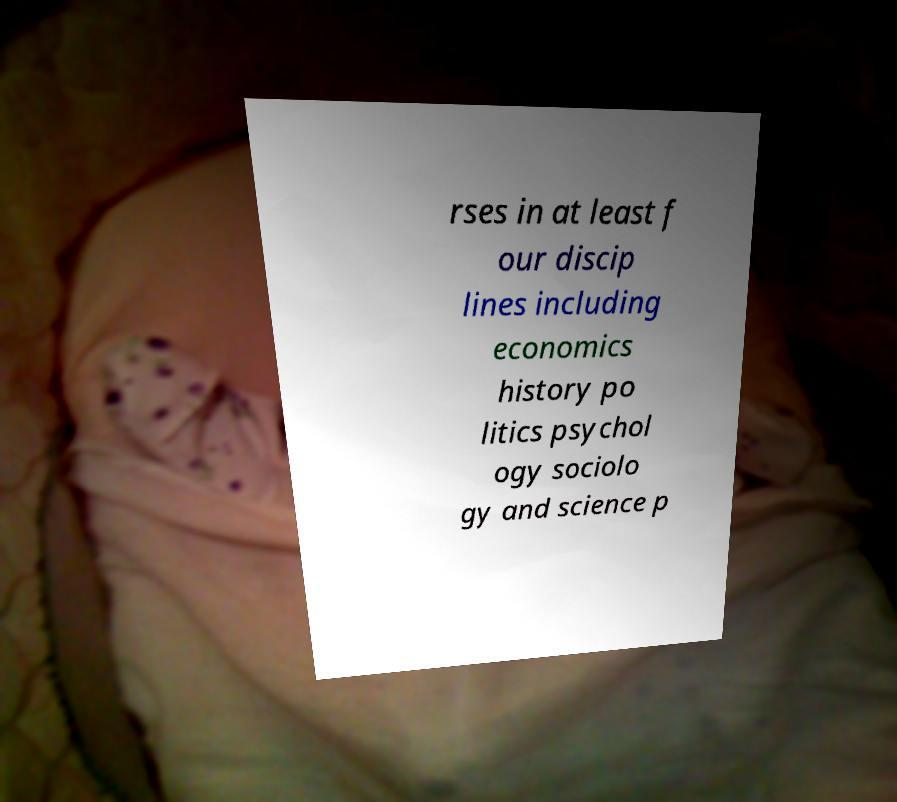Could you extract and type out the text from this image? rses in at least f our discip lines including economics history po litics psychol ogy sociolo gy and science p 